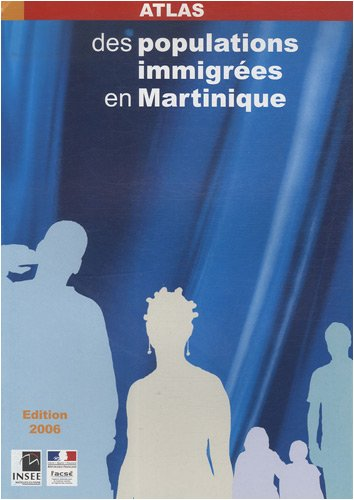What is the title of this book? The title of the book, as prominently displayed on its cover, is 'Atlas des populations immigrées en Martinique'. This indicates it likely contains statistical and demographic maps and data about immigrant populations in Martinique. 